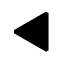Convert formula to latex. <formula><loc_0><loc_0><loc_500><loc_500>\blacktriangleleft</formula> 